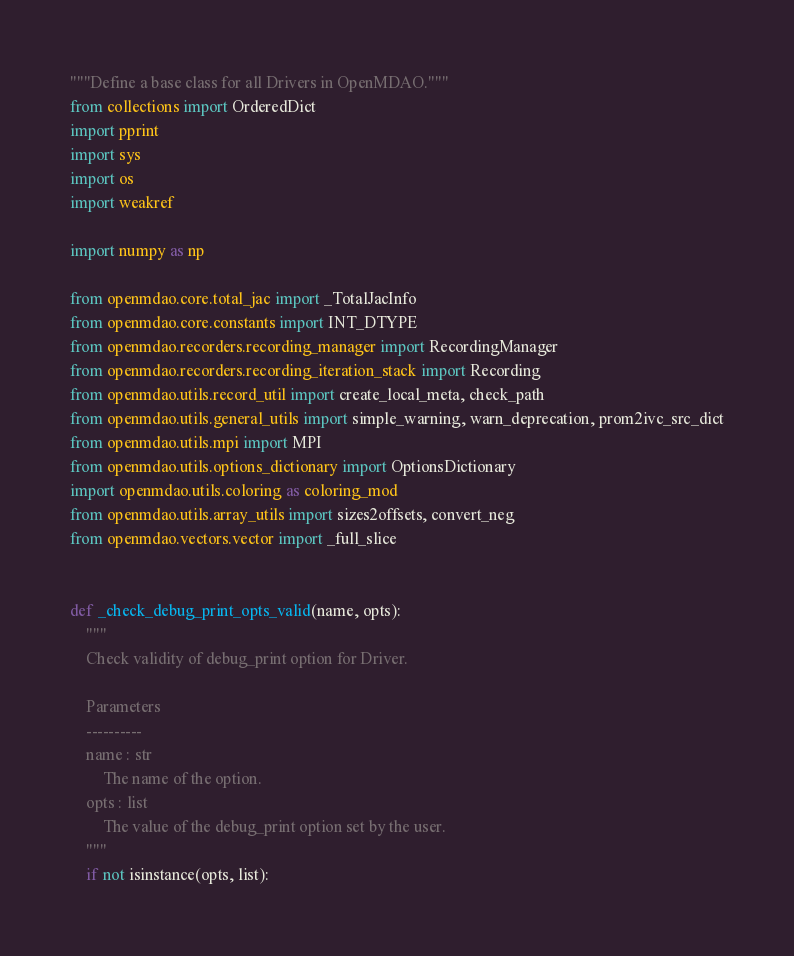Convert code to text. <code><loc_0><loc_0><loc_500><loc_500><_Python_>"""Define a base class for all Drivers in OpenMDAO."""
from collections import OrderedDict
import pprint
import sys
import os
import weakref

import numpy as np

from openmdao.core.total_jac import _TotalJacInfo
from openmdao.core.constants import INT_DTYPE
from openmdao.recorders.recording_manager import RecordingManager
from openmdao.recorders.recording_iteration_stack import Recording
from openmdao.utils.record_util import create_local_meta, check_path
from openmdao.utils.general_utils import simple_warning, warn_deprecation, prom2ivc_src_dict
from openmdao.utils.mpi import MPI
from openmdao.utils.options_dictionary import OptionsDictionary
import openmdao.utils.coloring as coloring_mod
from openmdao.utils.array_utils import sizes2offsets, convert_neg
from openmdao.vectors.vector import _full_slice


def _check_debug_print_opts_valid(name, opts):
    """
    Check validity of debug_print option for Driver.

    Parameters
    ----------
    name : str
        The name of the option.
    opts : list
        The value of the debug_print option set by the user.
    """
    if not isinstance(opts, list):</code> 